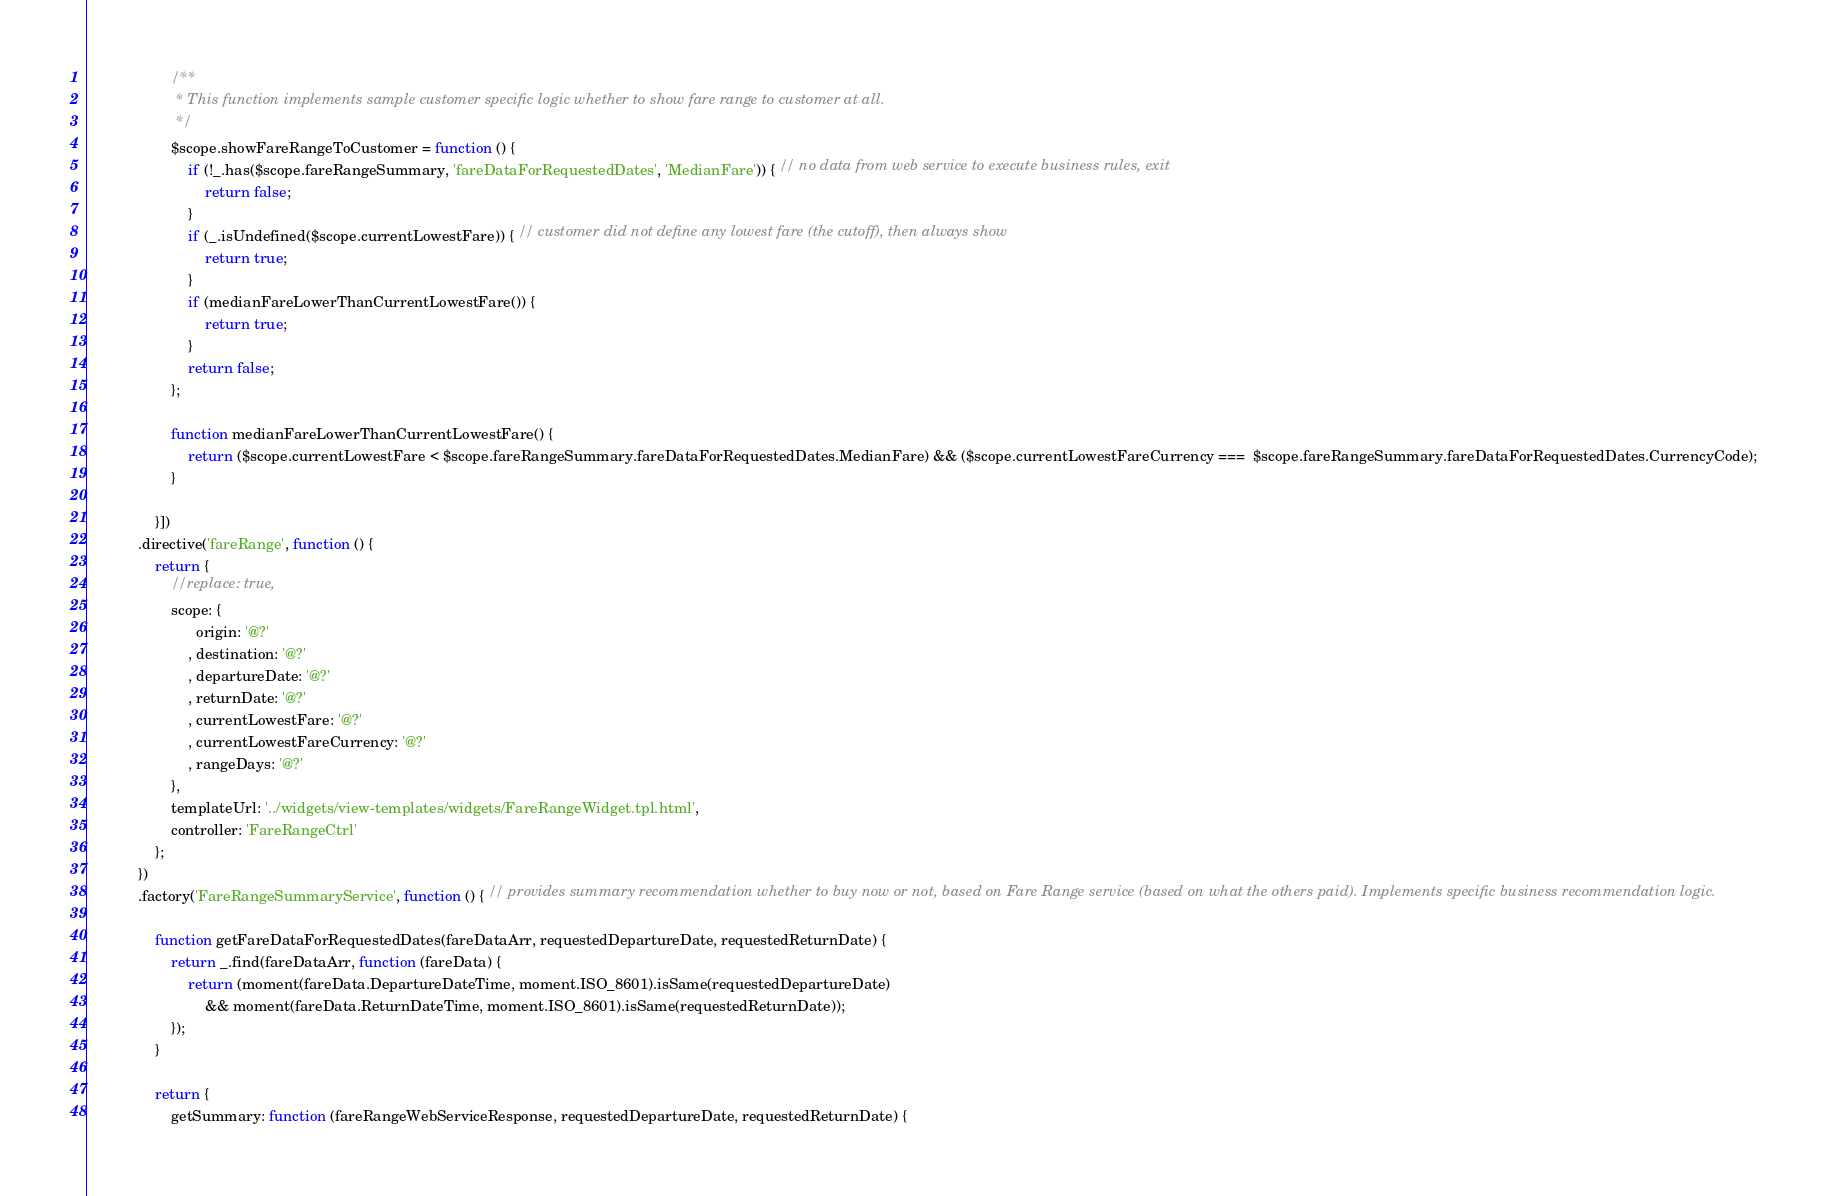Convert code to text. <code><loc_0><loc_0><loc_500><loc_500><_TypeScript_>
                    /**
                     * This function implements sample customer specific logic whether to show fare range to customer at all.
                     */
                    $scope.showFareRangeToCustomer = function () {
                        if (!_.has($scope.fareRangeSummary, 'fareDataForRequestedDates', 'MedianFare')) { // no data from web service to execute business rules, exit
                            return false;
                        }
                        if (_.isUndefined($scope.currentLowestFare)) { // customer did not define any lowest fare (the cutoff), then always show
                            return true;
                        }
                        if (medianFareLowerThanCurrentLowestFare()) {
                            return true;
                        }
                        return false;
                    };

                    function medianFareLowerThanCurrentLowestFare() {
                        return ($scope.currentLowestFare < $scope.fareRangeSummary.fareDataForRequestedDates.MedianFare) && ($scope.currentLowestFareCurrency ===  $scope.fareRangeSummary.fareDataForRequestedDates.CurrencyCode);
                    }

                }])
            .directive('fareRange', function () {
                return {
                    //replace: true,
                    scope: {
                          origin: '@?'
                        , destination: '@?'
                        , departureDate: '@?'
                        , returnDate: '@?'
                        , currentLowestFare: '@?'
                        , currentLowestFareCurrency: '@?'
                        , rangeDays: '@?'
                    },
                    templateUrl: '../widgets/view-templates/widgets/FareRangeWidget.tpl.html',
                    controller: 'FareRangeCtrl'
                };
            })
            .factory('FareRangeSummaryService', function () { // provides summary recommendation whether to buy now or not, based on Fare Range service (based on what the others paid). Implements specific business recommendation logic.

                function getFareDataForRequestedDates(fareDataArr, requestedDepartureDate, requestedReturnDate) {
                    return _.find(fareDataArr, function (fareData) {
                        return (moment(fareData.DepartureDateTime, moment.ISO_8601).isSame(requestedDepartureDate)
                            && moment(fareData.ReturnDateTime, moment.ISO_8601).isSame(requestedReturnDate));
                    });
                }

                return {
                    getSummary: function (fareRangeWebServiceResponse, requestedDepartureDate, requestedReturnDate) {</code> 